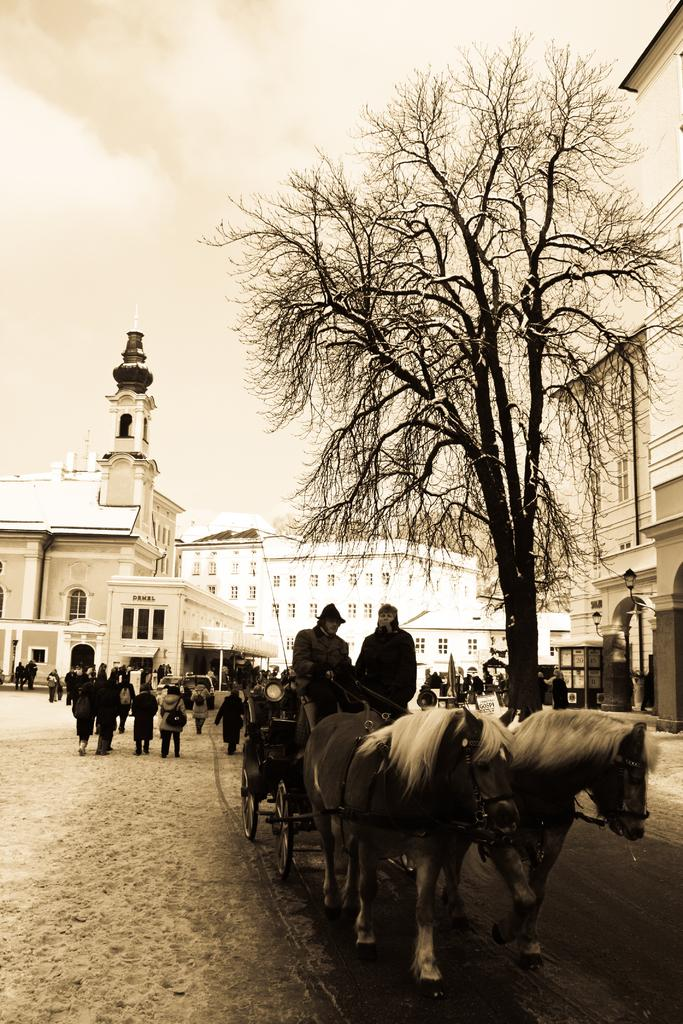What type of plant can be seen in the image? There is a tree in the image. What is the object made of wood in the image? There is a horse cart wheel in the image. What are the people in the image doing? There are people walking on the road in the image. What can be seen in the distance in the image? There is a building visible in the background of the image, and the sky is also visible. What type of honey can be seen dripping from the tree in the image? There is no honey present in the image; it features a tree, a horse cart wheel, people walking, a building in the background, and the sky. What kind of noise can be heard coming from the building in the image? There is no indication of any noise in the image, as it only shows visual elements. 